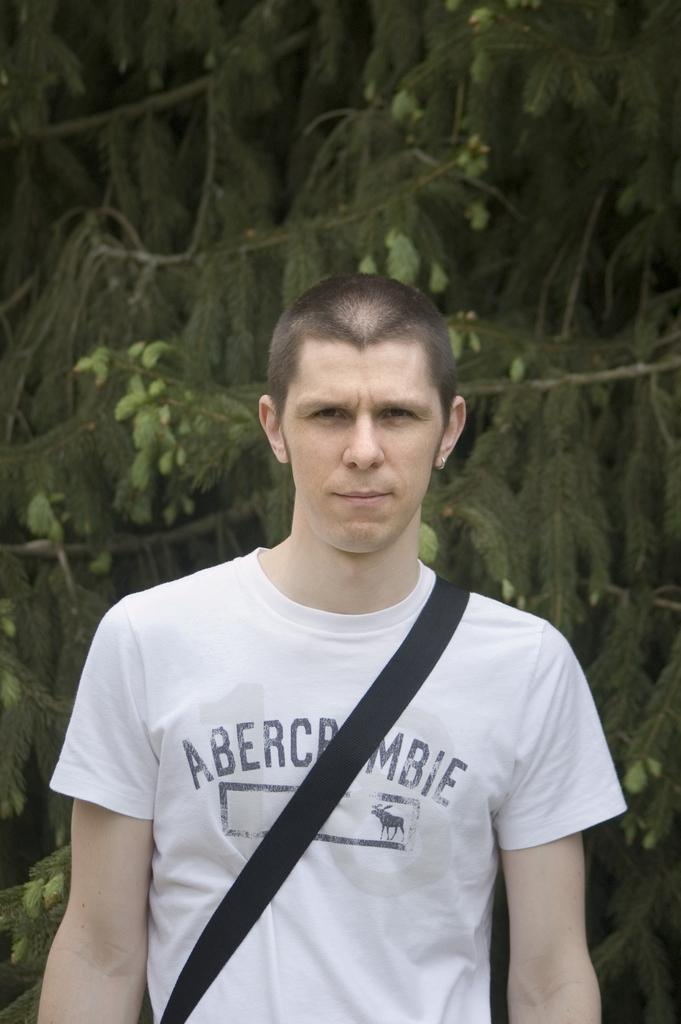What is the main subject of the image? The main subject of the image is a man. What can be seen in the background of the image? There are trees in the background of the image. What caused the man to sneeze in the image? There is no indication in the image that the man is sneezing or that there is a cause for a sneeze. 